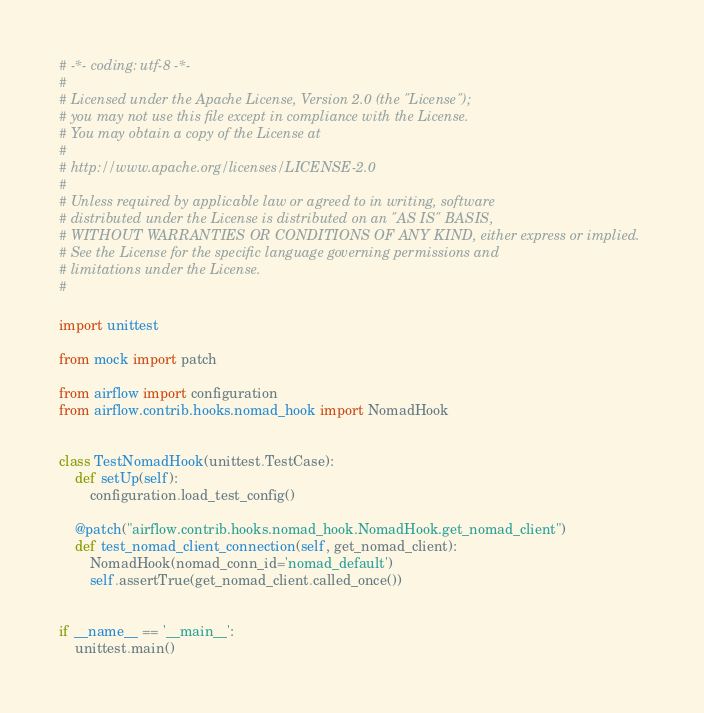Convert code to text. <code><loc_0><loc_0><loc_500><loc_500><_Python_># -*- coding: utf-8 -*-
#
# Licensed under the Apache License, Version 2.0 (the "License");
# you may not use this file except in compliance with the License.
# You may obtain a copy of the License at
#
# http://www.apache.org/licenses/LICENSE-2.0
#
# Unless required by applicable law or agreed to in writing, software
# distributed under the License is distributed on an "AS IS" BASIS,
# WITHOUT WARRANTIES OR CONDITIONS OF ANY KIND, either express or implied.
# See the License for the specific language governing permissions and
# limitations under the License.
#

import unittest

from mock import patch

from airflow import configuration
from airflow.contrib.hooks.nomad_hook import NomadHook


class TestNomadHook(unittest.TestCase):
    def setUp(self):
        configuration.load_test_config()

    @patch("airflow.contrib.hooks.nomad_hook.NomadHook.get_nomad_client")
    def test_nomad_client_connection(self, get_nomad_client):
        NomadHook(nomad_conn_id='nomad_default')
        self.assertTrue(get_nomad_client.called_once())


if __name__ == '__main__':
    unittest.main()
</code> 